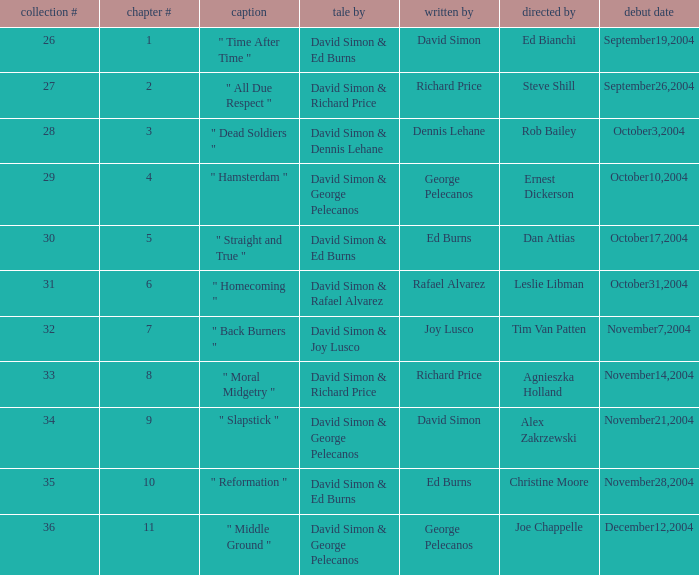What is the season # for a teleplay by Richard Price and the director is Steve Shill? 2.0. 